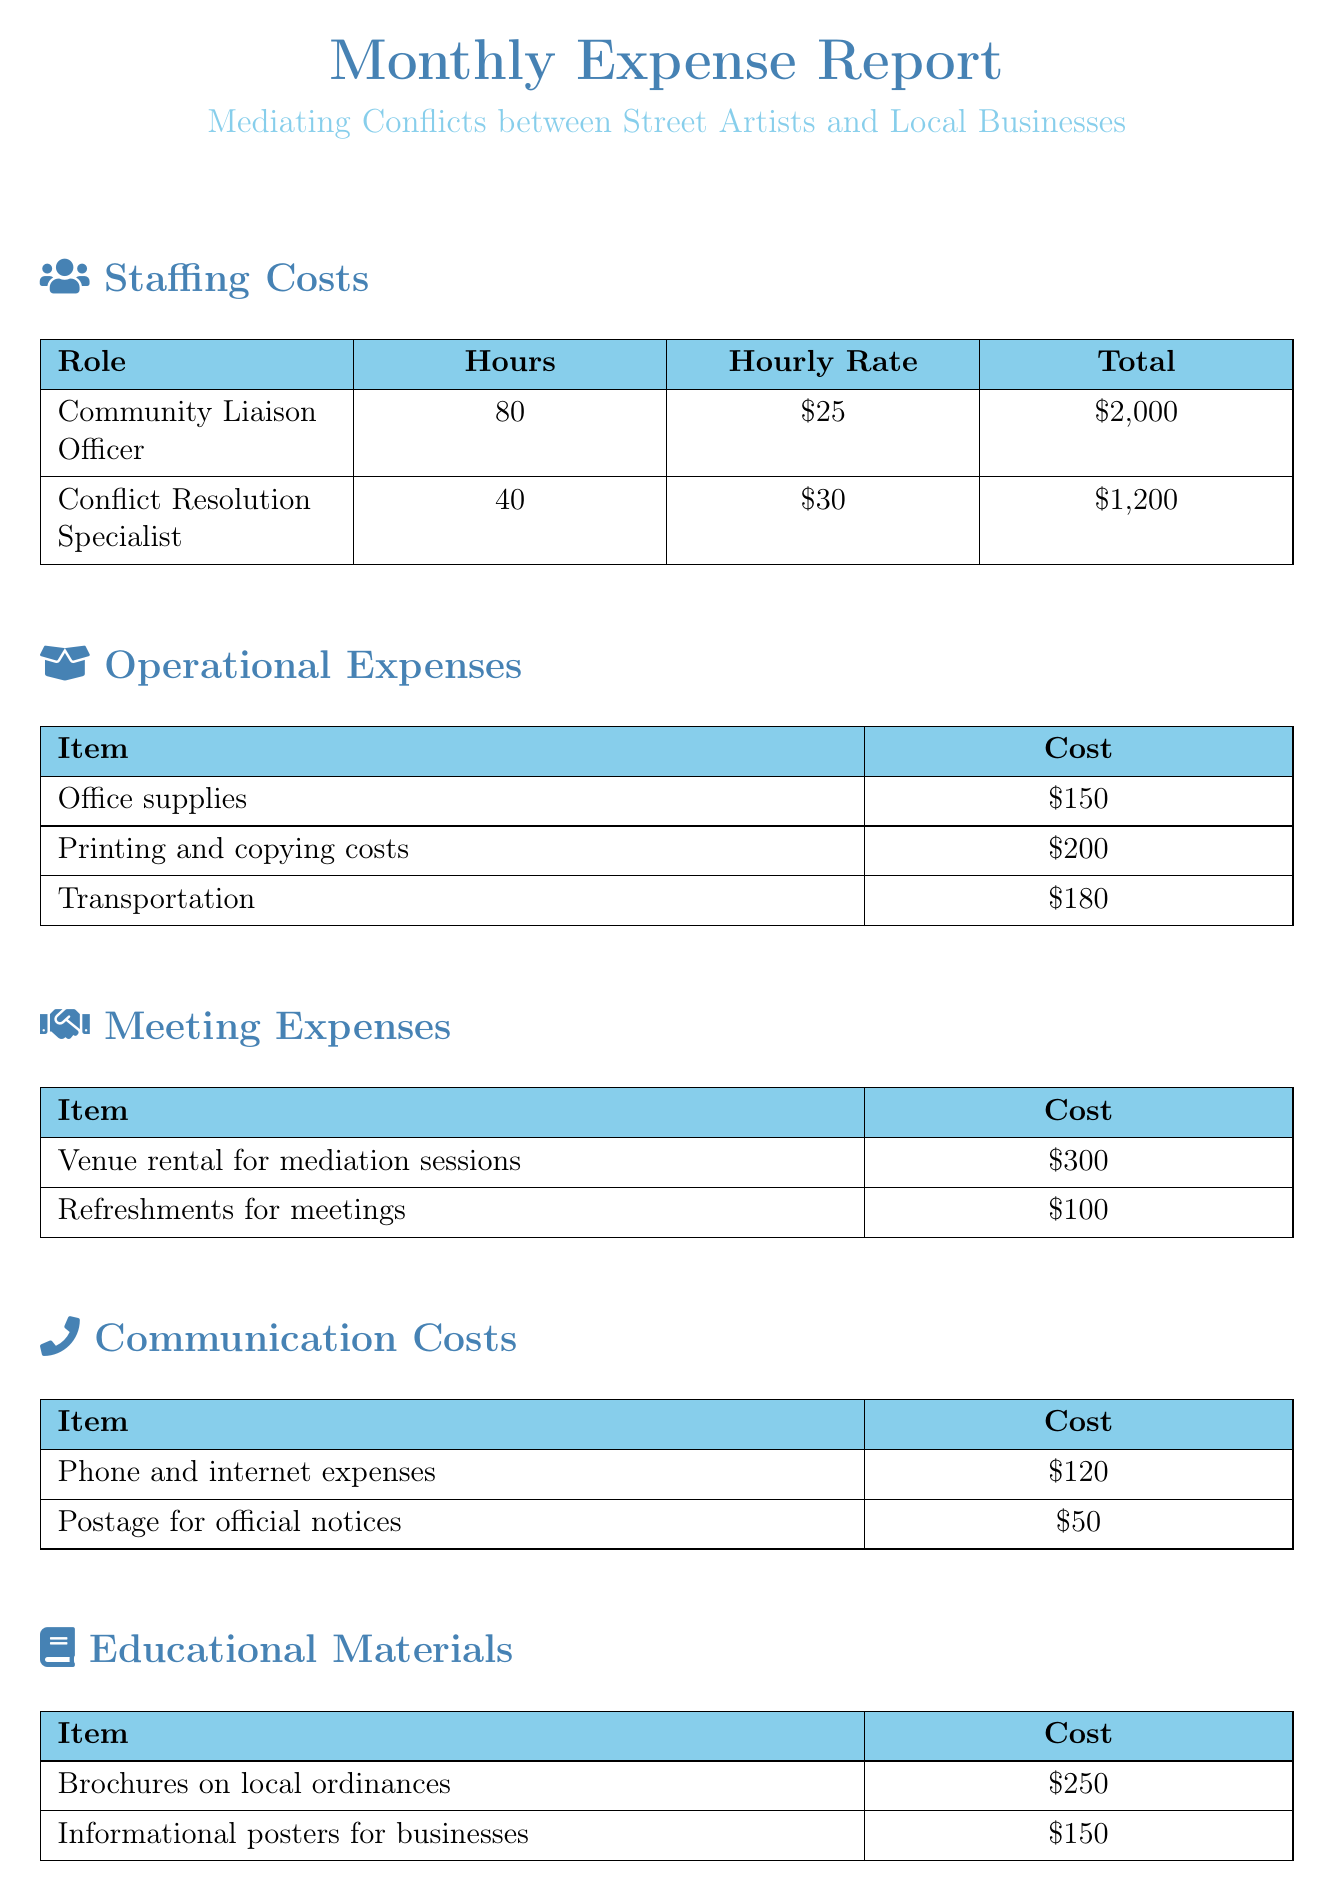What is the total cost for the Community Liaison Officer? The total cost for the Community Liaison Officer is given in the staffing costs section as $2,000.
Answer: $2,000 What is the hourly rate for the Conflict Resolution Specialist? The hourly rate for the Conflict Resolution Specialist is listed in the staffing costs section as $30.
Answer: $30 How much was spent on printing and copying costs? The amount spent on printing and copying costs is specified in the operational expenses section as $200.
Answer: $200 What is the cost for refreshments for meetings? The cost for refreshments for meetings is provided in the meeting expenses section as $100.
Answer: $100 How many hours were charged for the city attorney consultation? The document states that the city attorney consultation took 2 hours, which is specified in the legal consultation section.
Answer: 2 hours Which category had the highest total expense? Reasoning through the sections shows that staffing costs ($3,200) exceed all other categories, making it the highest.
Answer: Staffing Costs What is the total monthly expense? The total monthly expenses are clearly listed at the end of the document as $5,100.
Answer: $5,100 What item costs $150 in the educational materials section? The item costing $150 is specified as "Informational posters for businesses" in the educational materials section.
Answer: Informational posters for businesses How much was allocated for transportation? The transportation cost is indicated in the operational expenses section as $180.
Answer: $180 What is the total spent on phone and internet expenses? The total for phone and internet expenses is detailed in the communication costs section as $120.
Answer: $120 